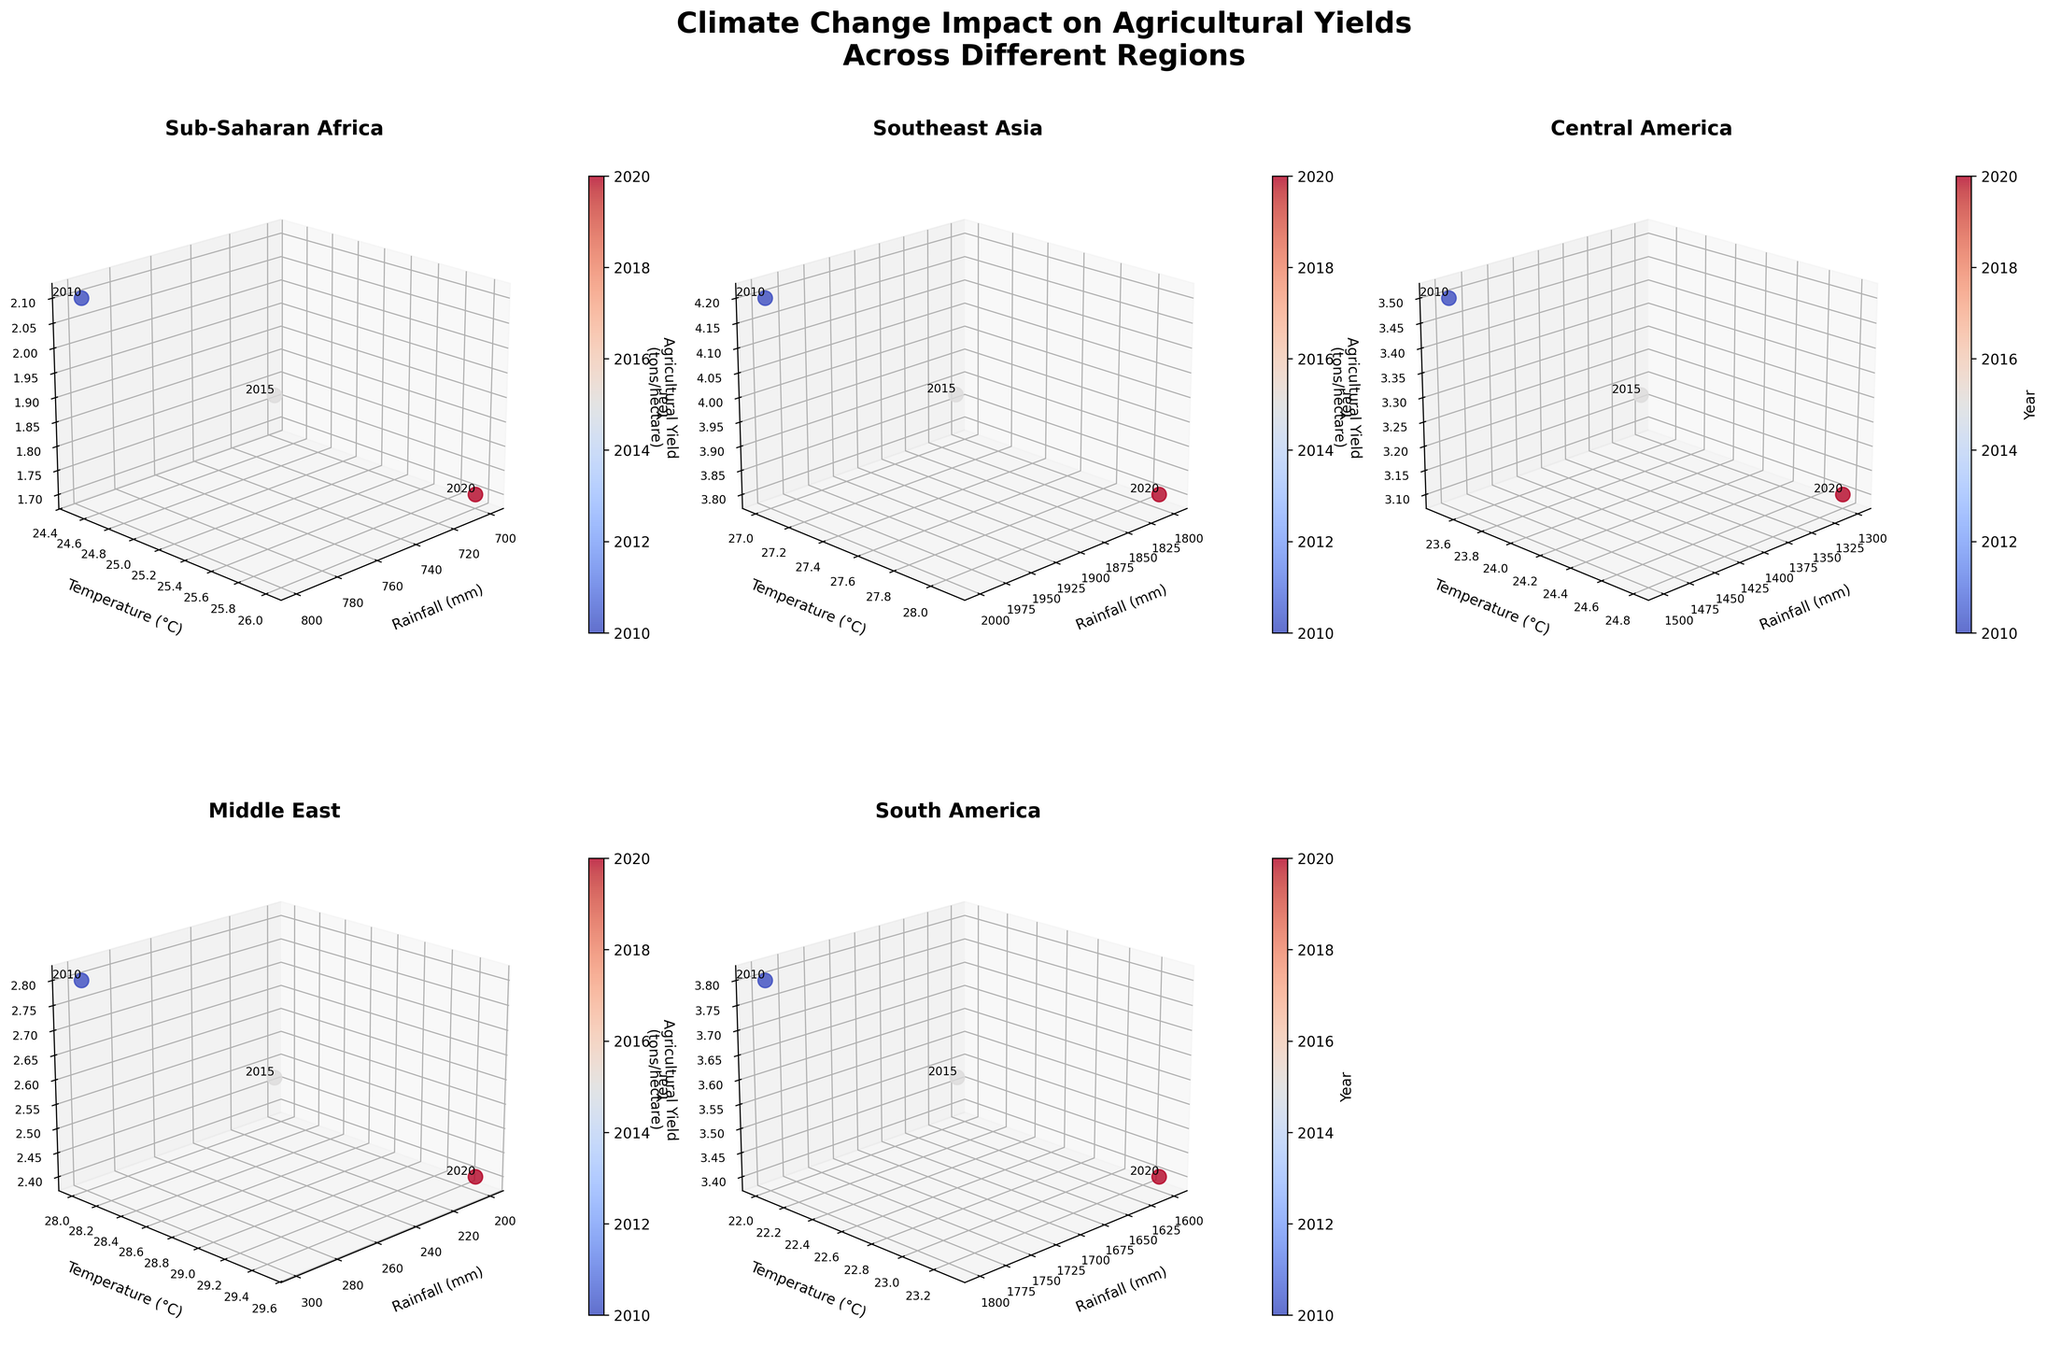How many regions are displayed in the figure? The figure shows six subplots, each corresponding to a specific region.
Answer: 6 Which region has the highest agricultural yield in 2020? By examining the data points for each subplot, South America shows the highest agricultural yield in 2020, with a value of 3.4 tons/hectare.
Answer: South America How does the temperature trend evolve in Southeast Asia from 2010 to 2020? Analyze each data point in Southeast Asia's subplot. The temperature increases from 27.0°C in 2010 to 28.1°C in 2020.
Answer: It increases What is the overall trend in rainfall for Sub-Saharan Africa? Assess the rainfall data for Sub-Saharan Africa across different years. It decreases over time, from 800 mm in 2010 to 700 mm in 2020.
Answer: It decreases Which region shows the steepest decline in agricultural yield? Compare the change in agricultural yield across all regions. The Middle East has the steepest decline, from 2.8 tons/hectare in 2010 to 2.4 tons/hectare in 2020.
Answer: Middle East Comparing South America and Central America, which region experiences higher temperatures in 2020? Identify the temperature data points for 2020 in both regions. South America has a temperature of 23.3°C, while Central America has 24.8°C.
Answer: Central America What correlation can you observe between rainfall and agricultural yield in Sub-Saharan Africa? Observe the subplot for Sub-Saharan Africa. Both rainfall and agricultural yield decrease over time, suggesting a positive correlation.
Answer: Positive correlation In which region does the temperature increase by the smallest margin between 2010 and 2020? Calculate the temperature difference for each region over the period. South America shows the smallest increase, from 22.0°C in 2010 to 23.3°C in 2020.
Answer: South America What's the average agricultural yield in Central America for the given years? The yields for Central America are 3.5, 3.3, and 3.1 tons/hectare for 2010, 2015, and 2020. Average = (3.5 + 3.3 + 3.1) / 3 = 3.3
Answer: 3.3 tons/hectare Which region has the highest annual rainfall across all the years presented? Review the rainfall data across all subplots and identify the highest values. Southeast Asia has the highest annual rainfall, peaking at 2000 mm in 2010.
Answer: Southeast Asia 